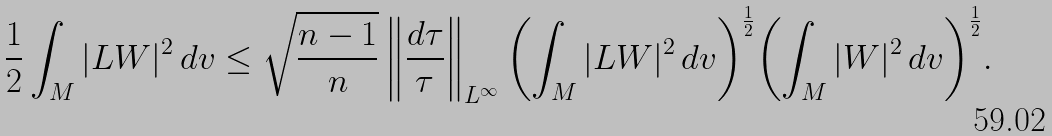<formula> <loc_0><loc_0><loc_500><loc_500>\frac { 1 } { 2 } \int _ { M } | L W | ^ { 2 } \, d v \leq \sqrt { \frac { n - 1 } { n } } \left \| \frac { d \tau } { \tau } \right \| _ { L ^ { \infty } } { \left ( \int _ { M } | L W | ^ { 2 } \, d v \right ) } ^ { \frac { 1 } { 2 } } { \left ( \int _ { M } | W | ^ { 2 } \, d v \right ) } ^ { \frac { 1 } { 2 } } .</formula> 